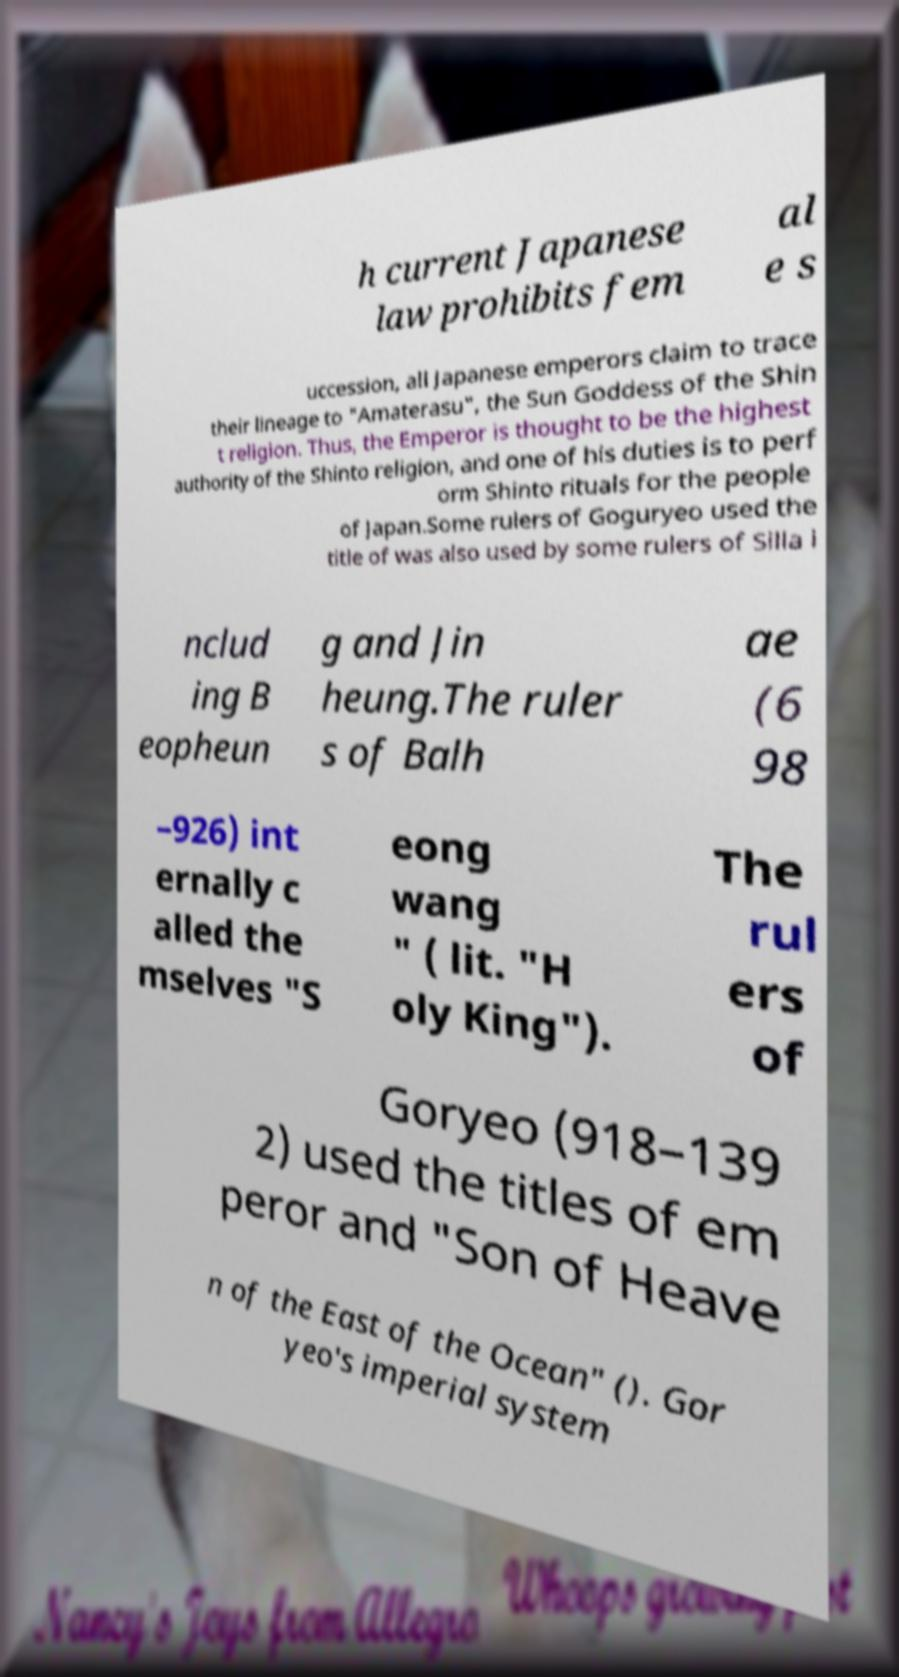Please identify and transcribe the text found in this image. h current Japanese law prohibits fem al e s uccession, all Japanese emperors claim to trace their lineage to "Amaterasu", the Sun Goddess of the Shin t religion. Thus, the Emperor is thought to be the highest authority of the Shinto religion, and one of his duties is to perf orm Shinto rituals for the people of Japan.Some rulers of Goguryeo used the title of was also used by some rulers of Silla i nclud ing B eopheun g and Jin heung.The ruler s of Balh ae (6 98 –926) int ernally c alled the mselves "S eong wang " ( lit. "H oly King"). The rul ers of Goryeo (918–139 2) used the titles of em peror and "Son of Heave n of the East of the Ocean" (). Gor yeo's imperial system 